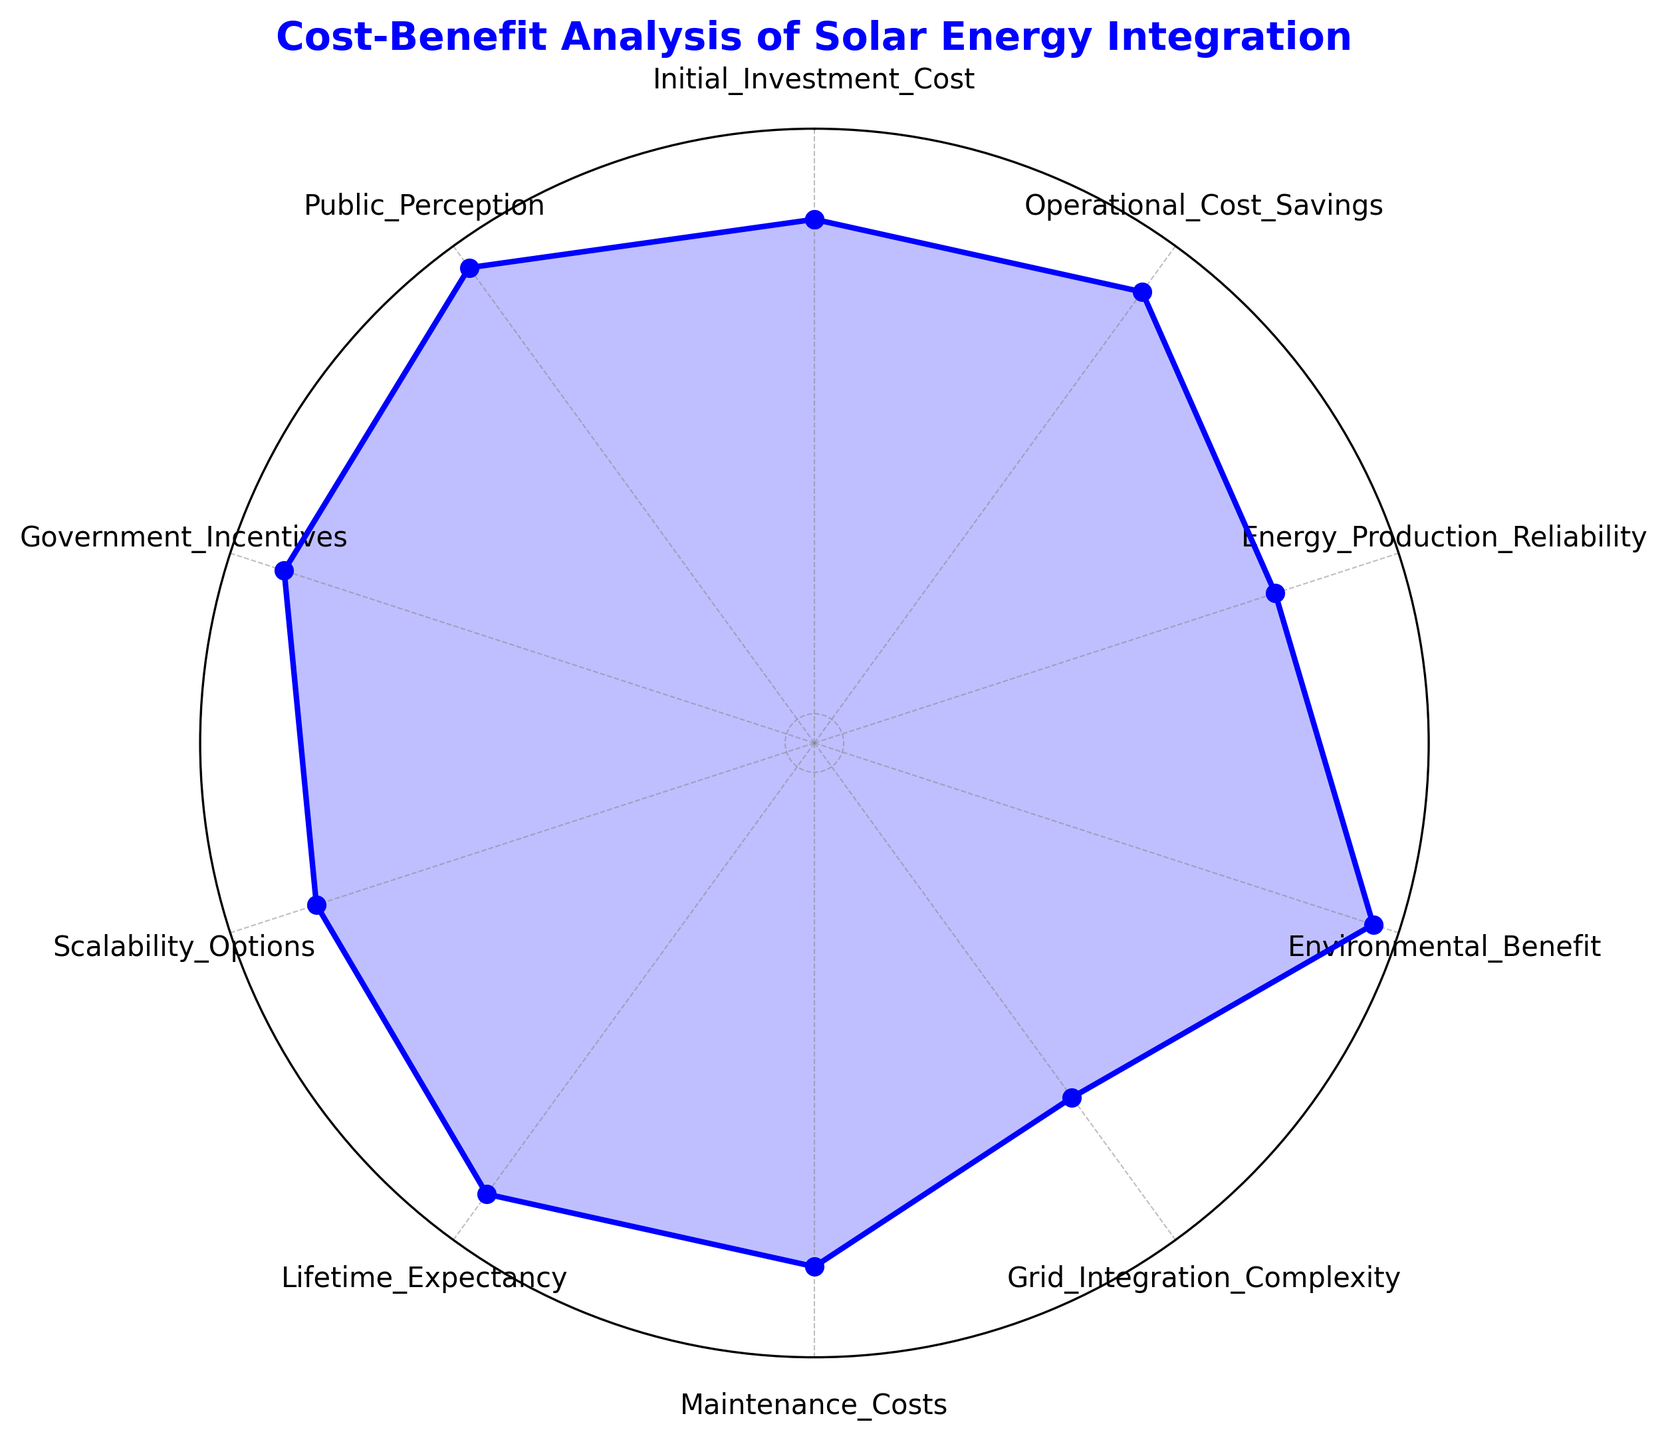What is the highest value metric in the radar chart? To find the highest value metric, look at the radar chart and identify which category has the highest point on the plot. The metric closest to the outermost circle represents the highest value.
Answer: Environmental_Benefit Which metric has the lowest value in the radar chart? To identify the lowest value, look for the innermost point on the radar chart. The metric associated with this point is the lowest value.
Answer: Grid_Integration_Complexity What is the sum of the values for Initial_Investment_Cost and Maintenance_Costs? First, locate the values for Initial_Investment_Cost and Maintenance_Costs on the radar chart. Initial_Investment_Cost is 7, and Maintenance_Costs is 7. Adding them together gives 7 + 7.
Answer: 14 Which metrics have a value of 8? Identify all the metrics on the radar chart with points lying on the same radius marked with the value 8. The metrics associated with these points are the ones with the value of 8.
Answer: Operational_Cost_Savings, Lifetime_Expectancy, Government_Incentives How many metrics have a value of 7? Count the number of points on the radar chart corresponding to the value of 7. The metrics with these points are considered.
Answer: 3 What is the difference between the values of Energy_Production_Reliability and Scalability_Options? Look at the values for Energy_Production_Reliability and Scalability_Options on the radar chart. Energy_Production_Reliability is 6, and Scalability_Options is 7. The difference is 7 - 6.
Answer: 1 What is the average value of all the metrics? To find the average, sum all the metric values and divide by the number of metrics. The values are 7, 8, 6, 9, 5, 7, 8, 7, 8, 9. Sum is 74, and there are 10 metrics. Divide 74 by 10.
Answer: 7.4 Which metrics share the same value as Initial_Investment_Cost? Identify the value of Initial_Investment_Cost on the radar chart, which is 7. Then look for other metrics that have points aligned with this value.
Answer: Maintenance_Costs, Scalability_Options Is Operational_Cost_Savings greater than Energy_Production_Reliability? Compare the values of Operational_Cost_Savings and Energy_Production_Reliability on the radar chart. Operational_Cost_Savings has a value of 8, while Energy_Production_Reliability has a value of 6.
Answer: Yes What metrics are visually the same height as Public_Perception? Locate the value of Public_Perception on the radar chart, which is represented at 9. Find all other metrics with points located at the same radial distance from the center, indicating they share the same height.
Answer: Environmental_Benefit 